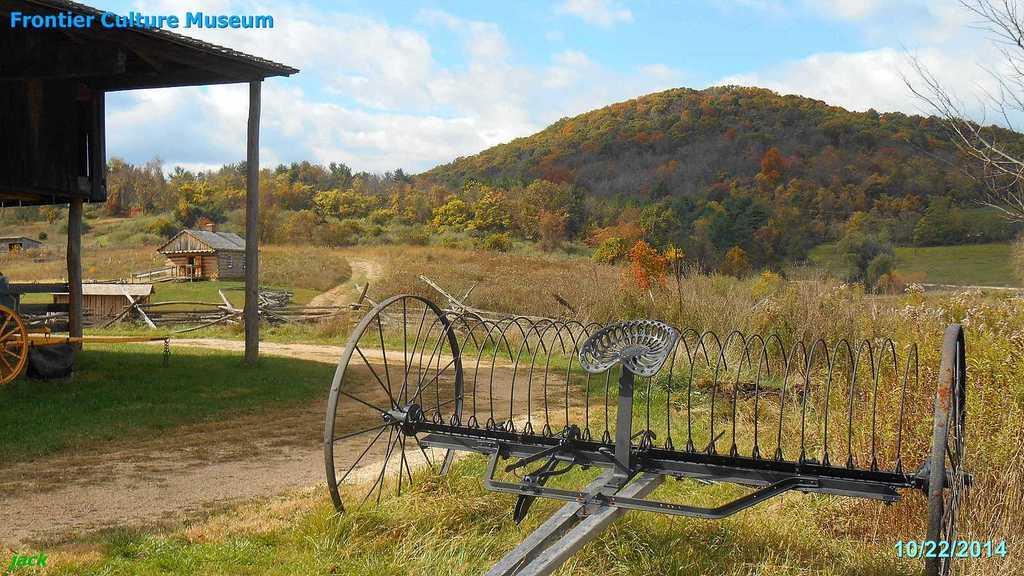How would you summarize this image in a sentence or two? In this picture there are houses and there are trees and there is a mountain. In the foreground there is a shed and there are vehicles. At the top there is sky and there are clouds. At the bottom there is grass. At the top left there is text. At the bottom right there are numbers. 